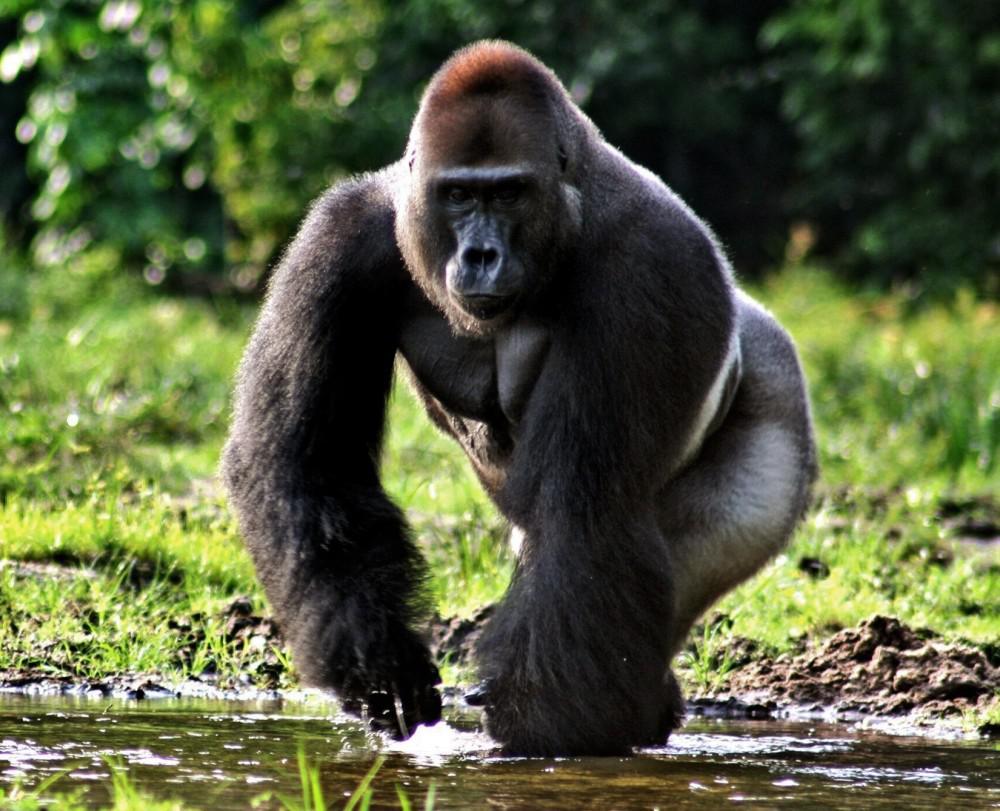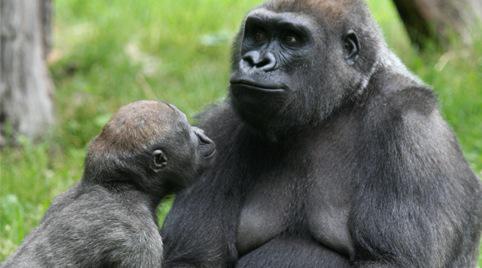The first image is the image on the left, the second image is the image on the right. For the images shown, is this caption "There are three gorillas" true? Answer yes or no. Yes. 